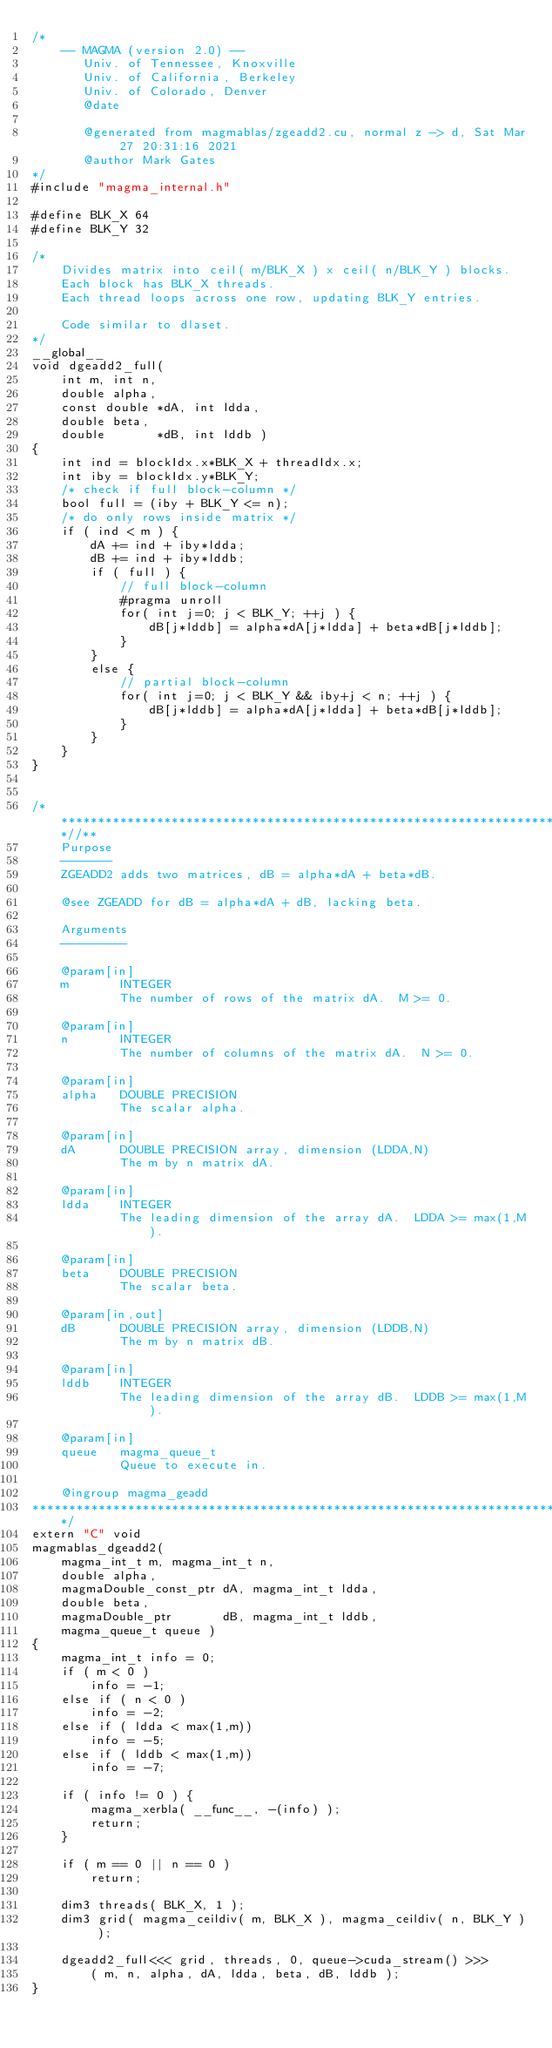Convert code to text. <code><loc_0><loc_0><loc_500><loc_500><_Cuda_>/*
    -- MAGMA (version 2.0) --
       Univ. of Tennessee, Knoxville
       Univ. of California, Berkeley
       Univ. of Colorado, Denver
       @date

       @generated from magmablas/zgeadd2.cu, normal z -> d, Sat Mar 27 20:31:16 2021
       @author Mark Gates
*/
#include "magma_internal.h"

#define BLK_X 64
#define BLK_Y 32

/*
    Divides matrix into ceil( m/BLK_X ) x ceil( n/BLK_Y ) blocks.
    Each block has BLK_X threads.
    Each thread loops across one row, updating BLK_Y entries.

    Code similar to dlaset.
*/
__global__
void dgeadd2_full(
    int m, int n,
    double alpha,
    const double *dA, int ldda,
    double beta,
    double       *dB, int lddb )
{
    int ind = blockIdx.x*BLK_X + threadIdx.x;
    int iby = blockIdx.y*BLK_Y;
    /* check if full block-column */
    bool full = (iby + BLK_Y <= n);
    /* do only rows inside matrix */
    if ( ind < m ) {
        dA += ind + iby*ldda;
        dB += ind + iby*lddb;
        if ( full ) {
            // full block-column
            #pragma unroll
            for( int j=0; j < BLK_Y; ++j ) {
                dB[j*lddb] = alpha*dA[j*ldda] + beta*dB[j*lddb];
            }
        }
        else {
            // partial block-column
            for( int j=0; j < BLK_Y && iby+j < n; ++j ) {
                dB[j*lddb] = alpha*dA[j*ldda] + beta*dB[j*lddb];
            }
        }
    }
}


/***************************************************************************//**
    Purpose
    -------
    ZGEADD2 adds two matrices, dB = alpha*dA + beta*dB.
    
    @see ZGEADD for dB = alpha*dA + dB, lacking beta.
    
    Arguments
    ---------
    
    @param[in]
    m       INTEGER
            The number of rows of the matrix dA.  M >= 0.
    
    @param[in]
    n       INTEGER
            The number of columns of the matrix dA.  N >= 0.
    
    @param[in]
    alpha   DOUBLE PRECISION
            The scalar alpha.
            
    @param[in]
    dA      DOUBLE PRECISION array, dimension (LDDA,N)
            The m by n matrix dA.
    
    @param[in]
    ldda    INTEGER
            The leading dimension of the array dA.  LDDA >= max(1,M).
    
    @param[in]
    beta    DOUBLE PRECISION
            The scalar beta.
            
    @param[in,out]
    dB      DOUBLE PRECISION array, dimension (LDDB,N)
            The m by n matrix dB.
    
    @param[in]
    lddb    INTEGER
            The leading dimension of the array dB.  LDDB >= max(1,M).
    
    @param[in]
    queue   magma_queue_t
            Queue to execute in.

    @ingroup magma_geadd
*******************************************************************************/
extern "C" void
magmablas_dgeadd2(
    magma_int_t m, magma_int_t n,
    double alpha,
    magmaDouble_const_ptr dA, magma_int_t ldda,
    double beta,
    magmaDouble_ptr       dB, magma_int_t lddb,
    magma_queue_t queue )
{
    magma_int_t info = 0;
    if ( m < 0 )
        info = -1;
    else if ( n < 0 )
        info = -2;
    else if ( ldda < max(1,m))
        info = -5;
    else if ( lddb < max(1,m))
        info = -7;
    
    if ( info != 0 ) {
        magma_xerbla( __func__, -(info) );
        return;
    }
    
    if ( m == 0 || n == 0 )
        return;
    
    dim3 threads( BLK_X, 1 );
    dim3 grid( magma_ceildiv( m, BLK_X ), magma_ceildiv( n, BLK_Y ) );
    
    dgeadd2_full<<< grid, threads, 0, queue->cuda_stream() >>>
        ( m, n, alpha, dA, ldda, beta, dB, lddb );
}
</code> 